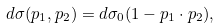Convert formula to latex. <formula><loc_0><loc_0><loc_500><loc_500>d \sigma ( { p } _ { 1 } , { p } _ { 2 } ) = d \sigma _ { 0 } ( 1 - { p } _ { 1 } \cdot { p } _ { 2 } ) ,</formula> 